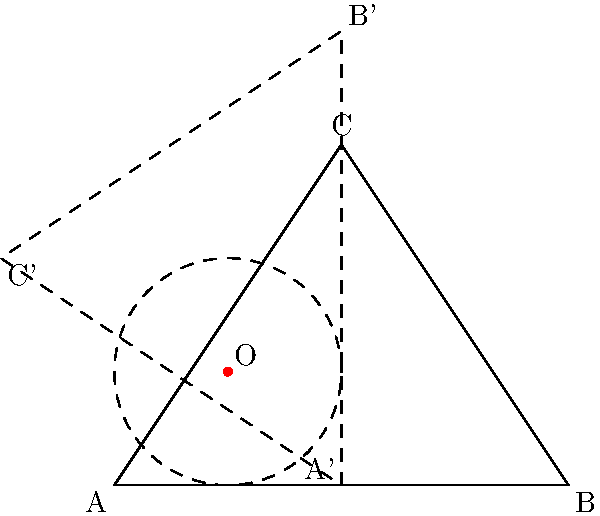In the triangular trading chart ABC, point O represents a critical support level. If we rotate the triangle 90° clockwise around point O to analyze a potential market trend reversal, what will be the coordinates of point C after rotation (C')? Express your answer in terms of the original coordinates of point C $(x,y)$ and the coordinates of point O $(a,b)$. To find the coordinates of C' after a 90° clockwise rotation around point O, we can follow these steps:

1) First, recall the general formula for rotating a point $(x,y)$ around a point $(a,b)$ by an angle $\theta$ clockwise:
   $x' = (x-a)\cos\theta + (y-b)\sin\theta + a$
   $y' = -(x-a)\sin\theta + (y-b)\cos\theta + b$

2) In our case, $\theta = 90°$, so $\cos\theta = 0$ and $\sin\theta = 1$

3) Substituting these values into our rotation formulas:
   $x' = (y-b) + a$
   $y' = -(x-a) + b$

4) Simplifying:
   $x' = y - b + a$
   $y' = -x + a + b$

5) These formulas give us the coordinates of C' $(x', y')$ in terms of the original coordinates of C $(x,y)$ and the center of rotation O $(a,b)$.
Answer: C': $(y-b+a, -x+a+b)$ 